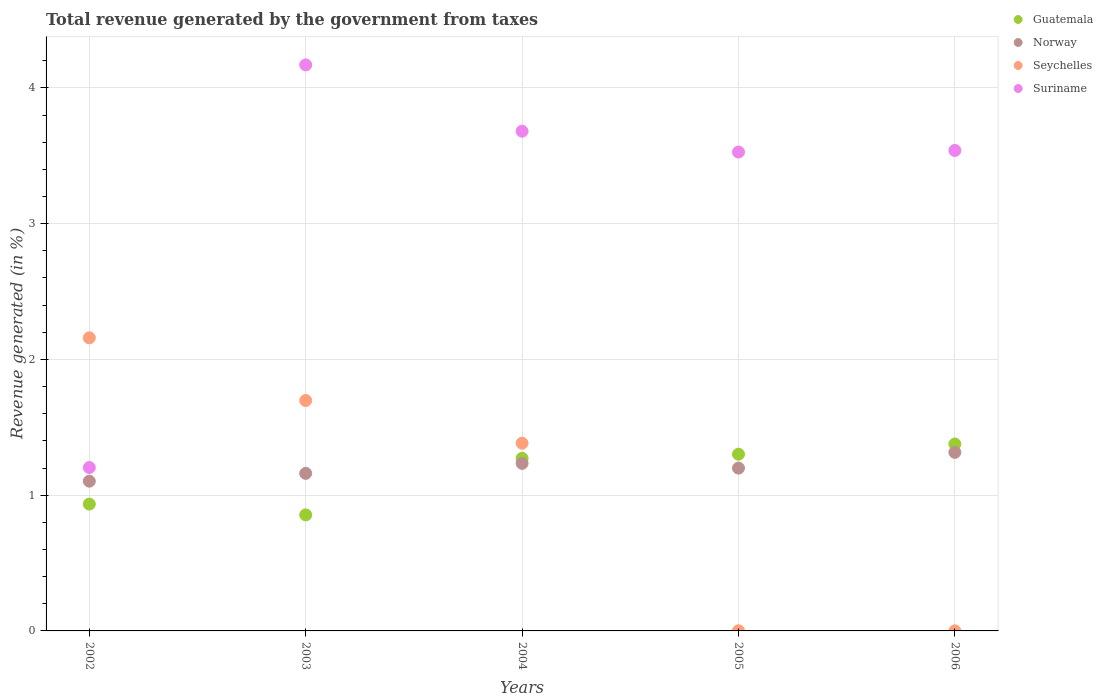Is the number of dotlines equal to the number of legend labels?
Your answer should be very brief. Yes. What is the total revenue generated in Suriname in 2006?
Offer a terse response. 3.54. Across all years, what is the maximum total revenue generated in Norway?
Offer a very short reply. 1.32. Across all years, what is the minimum total revenue generated in Guatemala?
Offer a very short reply. 0.85. What is the total total revenue generated in Guatemala in the graph?
Offer a very short reply. 5.74. What is the difference between the total revenue generated in Norway in 2003 and that in 2004?
Your answer should be compact. -0.07. What is the difference between the total revenue generated in Suriname in 2006 and the total revenue generated in Guatemala in 2005?
Give a very brief answer. 2.24. What is the average total revenue generated in Norway per year?
Provide a short and direct response. 1.2. In the year 2003, what is the difference between the total revenue generated in Seychelles and total revenue generated in Norway?
Offer a terse response. 0.54. What is the ratio of the total revenue generated in Guatemala in 2002 to that in 2004?
Keep it short and to the point. 0.73. Is the total revenue generated in Suriname in 2004 less than that in 2005?
Your answer should be compact. No. What is the difference between the highest and the second highest total revenue generated in Seychelles?
Offer a terse response. 0.46. What is the difference between the highest and the lowest total revenue generated in Seychelles?
Provide a succinct answer. 2.16. Is the sum of the total revenue generated in Norway in 2005 and 2006 greater than the maximum total revenue generated in Seychelles across all years?
Provide a succinct answer. Yes. Does the total revenue generated in Norway monotonically increase over the years?
Offer a very short reply. No. Is the total revenue generated in Suriname strictly greater than the total revenue generated in Guatemala over the years?
Your answer should be very brief. Yes. Is the total revenue generated in Suriname strictly less than the total revenue generated in Norway over the years?
Offer a very short reply. No. How many dotlines are there?
Provide a short and direct response. 4. Are the values on the major ticks of Y-axis written in scientific E-notation?
Your answer should be very brief. No. Does the graph contain any zero values?
Keep it short and to the point. No. What is the title of the graph?
Your response must be concise. Total revenue generated by the government from taxes. Does "Estonia" appear as one of the legend labels in the graph?
Give a very brief answer. No. What is the label or title of the Y-axis?
Offer a terse response. Revenue generated (in %). What is the Revenue generated (in %) of Guatemala in 2002?
Provide a succinct answer. 0.93. What is the Revenue generated (in %) in Norway in 2002?
Your answer should be very brief. 1.1. What is the Revenue generated (in %) of Seychelles in 2002?
Provide a succinct answer. 2.16. What is the Revenue generated (in %) of Suriname in 2002?
Provide a succinct answer. 1.2. What is the Revenue generated (in %) of Guatemala in 2003?
Offer a terse response. 0.85. What is the Revenue generated (in %) of Norway in 2003?
Give a very brief answer. 1.16. What is the Revenue generated (in %) in Seychelles in 2003?
Your answer should be compact. 1.7. What is the Revenue generated (in %) of Suriname in 2003?
Ensure brevity in your answer.  4.17. What is the Revenue generated (in %) of Guatemala in 2004?
Your response must be concise. 1.27. What is the Revenue generated (in %) of Norway in 2004?
Provide a short and direct response. 1.23. What is the Revenue generated (in %) of Seychelles in 2004?
Make the answer very short. 1.38. What is the Revenue generated (in %) in Suriname in 2004?
Provide a succinct answer. 3.68. What is the Revenue generated (in %) of Guatemala in 2005?
Offer a very short reply. 1.3. What is the Revenue generated (in %) in Norway in 2005?
Your response must be concise. 1.2. What is the Revenue generated (in %) in Seychelles in 2005?
Keep it short and to the point. 0. What is the Revenue generated (in %) in Suriname in 2005?
Offer a terse response. 3.53. What is the Revenue generated (in %) in Guatemala in 2006?
Provide a short and direct response. 1.38. What is the Revenue generated (in %) of Norway in 2006?
Offer a terse response. 1.32. What is the Revenue generated (in %) of Seychelles in 2006?
Your response must be concise. 0. What is the Revenue generated (in %) of Suriname in 2006?
Offer a terse response. 3.54. Across all years, what is the maximum Revenue generated (in %) in Guatemala?
Provide a succinct answer. 1.38. Across all years, what is the maximum Revenue generated (in %) in Norway?
Your answer should be very brief. 1.32. Across all years, what is the maximum Revenue generated (in %) of Seychelles?
Keep it short and to the point. 2.16. Across all years, what is the maximum Revenue generated (in %) in Suriname?
Keep it short and to the point. 4.17. Across all years, what is the minimum Revenue generated (in %) of Guatemala?
Offer a terse response. 0.85. Across all years, what is the minimum Revenue generated (in %) in Norway?
Offer a very short reply. 1.1. Across all years, what is the minimum Revenue generated (in %) in Seychelles?
Ensure brevity in your answer.  0. Across all years, what is the minimum Revenue generated (in %) of Suriname?
Offer a very short reply. 1.2. What is the total Revenue generated (in %) in Guatemala in the graph?
Your answer should be very brief. 5.74. What is the total Revenue generated (in %) in Norway in the graph?
Make the answer very short. 6.01. What is the total Revenue generated (in %) in Seychelles in the graph?
Keep it short and to the point. 5.24. What is the total Revenue generated (in %) in Suriname in the graph?
Give a very brief answer. 16.12. What is the difference between the Revenue generated (in %) of Guatemala in 2002 and that in 2003?
Ensure brevity in your answer.  0.08. What is the difference between the Revenue generated (in %) of Norway in 2002 and that in 2003?
Provide a succinct answer. -0.06. What is the difference between the Revenue generated (in %) in Seychelles in 2002 and that in 2003?
Your answer should be very brief. 0.46. What is the difference between the Revenue generated (in %) of Suriname in 2002 and that in 2003?
Keep it short and to the point. -2.97. What is the difference between the Revenue generated (in %) in Guatemala in 2002 and that in 2004?
Make the answer very short. -0.34. What is the difference between the Revenue generated (in %) of Norway in 2002 and that in 2004?
Make the answer very short. -0.13. What is the difference between the Revenue generated (in %) of Seychelles in 2002 and that in 2004?
Provide a short and direct response. 0.78. What is the difference between the Revenue generated (in %) of Suriname in 2002 and that in 2004?
Make the answer very short. -2.48. What is the difference between the Revenue generated (in %) in Guatemala in 2002 and that in 2005?
Keep it short and to the point. -0.37. What is the difference between the Revenue generated (in %) in Norway in 2002 and that in 2005?
Provide a succinct answer. -0.1. What is the difference between the Revenue generated (in %) of Seychelles in 2002 and that in 2005?
Give a very brief answer. 2.16. What is the difference between the Revenue generated (in %) in Suriname in 2002 and that in 2005?
Provide a short and direct response. -2.32. What is the difference between the Revenue generated (in %) of Guatemala in 2002 and that in 2006?
Make the answer very short. -0.44. What is the difference between the Revenue generated (in %) of Norway in 2002 and that in 2006?
Your response must be concise. -0.21. What is the difference between the Revenue generated (in %) of Seychelles in 2002 and that in 2006?
Your response must be concise. 2.16. What is the difference between the Revenue generated (in %) of Suriname in 2002 and that in 2006?
Your answer should be very brief. -2.34. What is the difference between the Revenue generated (in %) of Guatemala in 2003 and that in 2004?
Make the answer very short. -0.42. What is the difference between the Revenue generated (in %) of Norway in 2003 and that in 2004?
Offer a very short reply. -0.07. What is the difference between the Revenue generated (in %) of Seychelles in 2003 and that in 2004?
Keep it short and to the point. 0.31. What is the difference between the Revenue generated (in %) of Suriname in 2003 and that in 2004?
Make the answer very short. 0.49. What is the difference between the Revenue generated (in %) in Guatemala in 2003 and that in 2005?
Give a very brief answer. -0.45. What is the difference between the Revenue generated (in %) in Norway in 2003 and that in 2005?
Provide a short and direct response. -0.04. What is the difference between the Revenue generated (in %) in Seychelles in 2003 and that in 2005?
Keep it short and to the point. 1.7. What is the difference between the Revenue generated (in %) in Suriname in 2003 and that in 2005?
Give a very brief answer. 0.64. What is the difference between the Revenue generated (in %) of Guatemala in 2003 and that in 2006?
Offer a terse response. -0.52. What is the difference between the Revenue generated (in %) in Norway in 2003 and that in 2006?
Provide a short and direct response. -0.15. What is the difference between the Revenue generated (in %) in Seychelles in 2003 and that in 2006?
Give a very brief answer. 1.7. What is the difference between the Revenue generated (in %) in Suriname in 2003 and that in 2006?
Offer a very short reply. 0.63. What is the difference between the Revenue generated (in %) in Guatemala in 2004 and that in 2005?
Your response must be concise. -0.03. What is the difference between the Revenue generated (in %) of Norway in 2004 and that in 2005?
Offer a very short reply. 0.04. What is the difference between the Revenue generated (in %) in Seychelles in 2004 and that in 2005?
Provide a short and direct response. 1.38. What is the difference between the Revenue generated (in %) of Suriname in 2004 and that in 2005?
Offer a terse response. 0.15. What is the difference between the Revenue generated (in %) in Guatemala in 2004 and that in 2006?
Your answer should be very brief. -0.11. What is the difference between the Revenue generated (in %) of Norway in 2004 and that in 2006?
Provide a short and direct response. -0.08. What is the difference between the Revenue generated (in %) in Seychelles in 2004 and that in 2006?
Keep it short and to the point. 1.38. What is the difference between the Revenue generated (in %) in Suriname in 2004 and that in 2006?
Provide a succinct answer. 0.14. What is the difference between the Revenue generated (in %) of Guatemala in 2005 and that in 2006?
Your response must be concise. -0.08. What is the difference between the Revenue generated (in %) in Norway in 2005 and that in 2006?
Offer a terse response. -0.12. What is the difference between the Revenue generated (in %) of Seychelles in 2005 and that in 2006?
Provide a succinct answer. 0. What is the difference between the Revenue generated (in %) of Suriname in 2005 and that in 2006?
Give a very brief answer. -0.01. What is the difference between the Revenue generated (in %) of Guatemala in 2002 and the Revenue generated (in %) of Norway in 2003?
Provide a succinct answer. -0.23. What is the difference between the Revenue generated (in %) in Guatemala in 2002 and the Revenue generated (in %) in Seychelles in 2003?
Offer a very short reply. -0.76. What is the difference between the Revenue generated (in %) in Guatemala in 2002 and the Revenue generated (in %) in Suriname in 2003?
Your response must be concise. -3.24. What is the difference between the Revenue generated (in %) of Norway in 2002 and the Revenue generated (in %) of Seychelles in 2003?
Keep it short and to the point. -0.59. What is the difference between the Revenue generated (in %) of Norway in 2002 and the Revenue generated (in %) of Suriname in 2003?
Make the answer very short. -3.07. What is the difference between the Revenue generated (in %) in Seychelles in 2002 and the Revenue generated (in %) in Suriname in 2003?
Make the answer very short. -2.01. What is the difference between the Revenue generated (in %) of Guatemala in 2002 and the Revenue generated (in %) of Norway in 2004?
Offer a terse response. -0.3. What is the difference between the Revenue generated (in %) of Guatemala in 2002 and the Revenue generated (in %) of Seychelles in 2004?
Offer a very short reply. -0.45. What is the difference between the Revenue generated (in %) in Guatemala in 2002 and the Revenue generated (in %) in Suriname in 2004?
Provide a short and direct response. -2.75. What is the difference between the Revenue generated (in %) of Norway in 2002 and the Revenue generated (in %) of Seychelles in 2004?
Make the answer very short. -0.28. What is the difference between the Revenue generated (in %) in Norway in 2002 and the Revenue generated (in %) in Suriname in 2004?
Provide a short and direct response. -2.58. What is the difference between the Revenue generated (in %) in Seychelles in 2002 and the Revenue generated (in %) in Suriname in 2004?
Make the answer very short. -1.52. What is the difference between the Revenue generated (in %) of Guatemala in 2002 and the Revenue generated (in %) of Norway in 2005?
Make the answer very short. -0.26. What is the difference between the Revenue generated (in %) in Guatemala in 2002 and the Revenue generated (in %) in Suriname in 2005?
Your answer should be compact. -2.59. What is the difference between the Revenue generated (in %) of Norway in 2002 and the Revenue generated (in %) of Seychelles in 2005?
Make the answer very short. 1.1. What is the difference between the Revenue generated (in %) of Norway in 2002 and the Revenue generated (in %) of Suriname in 2005?
Your answer should be very brief. -2.42. What is the difference between the Revenue generated (in %) of Seychelles in 2002 and the Revenue generated (in %) of Suriname in 2005?
Give a very brief answer. -1.37. What is the difference between the Revenue generated (in %) in Guatemala in 2002 and the Revenue generated (in %) in Norway in 2006?
Your response must be concise. -0.38. What is the difference between the Revenue generated (in %) of Guatemala in 2002 and the Revenue generated (in %) of Seychelles in 2006?
Keep it short and to the point. 0.93. What is the difference between the Revenue generated (in %) of Guatemala in 2002 and the Revenue generated (in %) of Suriname in 2006?
Provide a short and direct response. -2.61. What is the difference between the Revenue generated (in %) of Norway in 2002 and the Revenue generated (in %) of Seychelles in 2006?
Provide a short and direct response. 1.1. What is the difference between the Revenue generated (in %) in Norway in 2002 and the Revenue generated (in %) in Suriname in 2006?
Offer a terse response. -2.44. What is the difference between the Revenue generated (in %) in Seychelles in 2002 and the Revenue generated (in %) in Suriname in 2006?
Your response must be concise. -1.38. What is the difference between the Revenue generated (in %) in Guatemala in 2003 and the Revenue generated (in %) in Norway in 2004?
Keep it short and to the point. -0.38. What is the difference between the Revenue generated (in %) of Guatemala in 2003 and the Revenue generated (in %) of Seychelles in 2004?
Offer a terse response. -0.53. What is the difference between the Revenue generated (in %) in Guatemala in 2003 and the Revenue generated (in %) in Suriname in 2004?
Offer a very short reply. -2.83. What is the difference between the Revenue generated (in %) in Norway in 2003 and the Revenue generated (in %) in Seychelles in 2004?
Your response must be concise. -0.22. What is the difference between the Revenue generated (in %) of Norway in 2003 and the Revenue generated (in %) of Suriname in 2004?
Offer a terse response. -2.52. What is the difference between the Revenue generated (in %) of Seychelles in 2003 and the Revenue generated (in %) of Suriname in 2004?
Your response must be concise. -1.98. What is the difference between the Revenue generated (in %) in Guatemala in 2003 and the Revenue generated (in %) in Norway in 2005?
Keep it short and to the point. -0.34. What is the difference between the Revenue generated (in %) of Guatemala in 2003 and the Revenue generated (in %) of Seychelles in 2005?
Offer a very short reply. 0.85. What is the difference between the Revenue generated (in %) of Guatemala in 2003 and the Revenue generated (in %) of Suriname in 2005?
Make the answer very short. -2.67. What is the difference between the Revenue generated (in %) in Norway in 2003 and the Revenue generated (in %) in Seychelles in 2005?
Offer a very short reply. 1.16. What is the difference between the Revenue generated (in %) of Norway in 2003 and the Revenue generated (in %) of Suriname in 2005?
Give a very brief answer. -2.37. What is the difference between the Revenue generated (in %) in Seychelles in 2003 and the Revenue generated (in %) in Suriname in 2005?
Your response must be concise. -1.83. What is the difference between the Revenue generated (in %) of Guatemala in 2003 and the Revenue generated (in %) of Norway in 2006?
Your response must be concise. -0.46. What is the difference between the Revenue generated (in %) in Guatemala in 2003 and the Revenue generated (in %) in Seychelles in 2006?
Ensure brevity in your answer.  0.85. What is the difference between the Revenue generated (in %) of Guatemala in 2003 and the Revenue generated (in %) of Suriname in 2006?
Keep it short and to the point. -2.68. What is the difference between the Revenue generated (in %) of Norway in 2003 and the Revenue generated (in %) of Seychelles in 2006?
Offer a very short reply. 1.16. What is the difference between the Revenue generated (in %) in Norway in 2003 and the Revenue generated (in %) in Suriname in 2006?
Offer a very short reply. -2.38. What is the difference between the Revenue generated (in %) of Seychelles in 2003 and the Revenue generated (in %) of Suriname in 2006?
Your answer should be very brief. -1.84. What is the difference between the Revenue generated (in %) of Guatemala in 2004 and the Revenue generated (in %) of Norway in 2005?
Keep it short and to the point. 0.07. What is the difference between the Revenue generated (in %) in Guatemala in 2004 and the Revenue generated (in %) in Seychelles in 2005?
Provide a short and direct response. 1.27. What is the difference between the Revenue generated (in %) of Guatemala in 2004 and the Revenue generated (in %) of Suriname in 2005?
Offer a very short reply. -2.26. What is the difference between the Revenue generated (in %) of Norway in 2004 and the Revenue generated (in %) of Seychelles in 2005?
Provide a succinct answer. 1.23. What is the difference between the Revenue generated (in %) of Norway in 2004 and the Revenue generated (in %) of Suriname in 2005?
Provide a succinct answer. -2.29. What is the difference between the Revenue generated (in %) in Seychelles in 2004 and the Revenue generated (in %) in Suriname in 2005?
Provide a short and direct response. -2.14. What is the difference between the Revenue generated (in %) of Guatemala in 2004 and the Revenue generated (in %) of Norway in 2006?
Keep it short and to the point. -0.04. What is the difference between the Revenue generated (in %) of Guatemala in 2004 and the Revenue generated (in %) of Seychelles in 2006?
Your answer should be compact. 1.27. What is the difference between the Revenue generated (in %) in Guatemala in 2004 and the Revenue generated (in %) in Suriname in 2006?
Offer a terse response. -2.27. What is the difference between the Revenue generated (in %) in Norway in 2004 and the Revenue generated (in %) in Seychelles in 2006?
Your response must be concise. 1.23. What is the difference between the Revenue generated (in %) of Norway in 2004 and the Revenue generated (in %) of Suriname in 2006?
Keep it short and to the point. -2.31. What is the difference between the Revenue generated (in %) in Seychelles in 2004 and the Revenue generated (in %) in Suriname in 2006?
Keep it short and to the point. -2.16. What is the difference between the Revenue generated (in %) in Guatemala in 2005 and the Revenue generated (in %) in Norway in 2006?
Offer a terse response. -0.01. What is the difference between the Revenue generated (in %) of Guatemala in 2005 and the Revenue generated (in %) of Seychelles in 2006?
Keep it short and to the point. 1.3. What is the difference between the Revenue generated (in %) of Guatemala in 2005 and the Revenue generated (in %) of Suriname in 2006?
Offer a terse response. -2.24. What is the difference between the Revenue generated (in %) of Norway in 2005 and the Revenue generated (in %) of Seychelles in 2006?
Make the answer very short. 1.2. What is the difference between the Revenue generated (in %) of Norway in 2005 and the Revenue generated (in %) of Suriname in 2006?
Ensure brevity in your answer.  -2.34. What is the difference between the Revenue generated (in %) in Seychelles in 2005 and the Revenue generated (in %) in Suriname in 2006?
Give a very brief answer. -3.54. What is the average Revenue generated (in %) in Guatemala per year?
Provide a short and direct response. 1.15. What is the average Revenue generated (in %) of Norway per year?
Give a very brief answer. 1.2. What is the average Revenue generated (in %) in Seychelles per year?
Give a very brief answer. 1.05. What is the average Revenue generated (in %) of Suriname per year?
Your response must be concise. 3.22. In the year 2002, what is the difference between the Revenue generated (in %) in Guatemala and Revenue generated (in %) in Norway?
Offer a very short reply. -0.17. In the year 2002, what is the difference between the Revenue generated (in %) in Guatemala and Revenue generated (in %) in Seychelles?
Your answer should be compact. -1.22. In the year 2002, what is the difference between the Revenue generated (in %) of Guatemala and Revenue generated (in %) of Suriname?
Your answer should be very brief. -0.27. In the year 2002, what is the difference between the Revenue generated (in %) in Norway and Revenue generated (in %) in Seychelles?
Provide a succinct answer. -1.06. In the year 2002, what is the difference between the Revenue generated (in %) of Norway and Revenue generated (in %) of Suriname?
Give a very brief answer. -0.1. In the year 2002, what is the difference between the Revenue generated (in %) in Seychelles and Revenue generated (in %) in Suriname?
Ensure brevity in your answer.  0.96. In the year 2003, what is the difference between the Revenue generated (in %) in Guatemala and Revenue generated (in %) in Norway?
Offer a terse response. -0.31. In the year 2003, what is the difference between the Revenue generated (in %) in Guatemala and Revenue generated (in %) in Seychelles?
Make the answer very short. -0.84. In the year 2003, what is the difference between the Revenue generated (in %) of Guatemala and Revenue generated (in %) of Suriname?
Give a very brief answer. -3.31. In the year 2003, what is the difference between the Revenue generated (in %) of Norway and Revenue generated (in %) of Seychelles?
Provide a short and direct response. -0.54. In the year 2003, what is the difference between the Revenue generated (in %) in Norway and Revenue generated (in %) in Suriname?
Give a very brief answer. -3.01. In the year 2003, what is the difference between the Revenue generated (in %) of Seychelles and Revenue generated (in %) of Suriname?
Give a very brief answer. -2.47. In the year 2004, what is the difference between the Revenue generated (in %) of Guatemala and Revenue generated (in %) of Norway?
Provide a short and direct response. 0.04. In the year 2004, what is the difference between the Revenue generated (in %) in Guatemala and Revenue generated (in %) in Seychelles?
Your answer should be compact. -0.11. In the year 2004, what is the difference between the Revenue generated (in %) of Guatemala and Revenue generated (in %) of Suriname?
Your response must be concise. -2.41. In the year 2004, what is the difference between the Revenue generated (in %) of Norway and Revenue generated (in %) of Seychelles?
Keep it short and to the point. -0.15. In the year 2004, what is the difference between the Revenue generated (in %) in Norway and Revenue generated (in %) in Suriname?
Your answer should be very brief. -2.45. In the year 2004, what is the difference between the Revenue generated (in %) in Seychelles and Revenue generated (in %) in Suriname?
Your answer should be compact. -2.3. In the year 2005, what is the difference between the Revenue generated (in %) in Guatemala and Revenue generated (in %) in Norway?
Offer a very short reply. 0.1. In the year 2005, what is the difference between the Revenue generated (in %) in Guatemala and Revenue generated (in %) in Seychelles?
Make the answer very short. 1.3. In the year 2005, what is the difference between the Revenue generated (in %) in Guatemala and Revenue generated (in %) in Suriname?
Make the answer very short. -2.23. In the year 2005, what is the difference between the Revenue generated (in %) of Norway and Revenue generated (in %) of Seychelles?
Make the answer very short. 1.2. In the year 2005, what is the difference between the Revenue generated (in %) of Norway and Revenue generated (in %) of Suriname?
Keep it short and to the point. -2.33. In the year 2005, what is the difference between the Revenue generated (in %) in Seychelles and Revenue generated (in %) in Suriname?
Provide a succinct answer. -3.53. In the year 2006, what is the difference between the Revenue generated (in %) in Guatemala and Revenue generated (in %) in Norway?
Offer a very short reply. 0.06. In the year 2006, what is the difference between the Revenue generated (in %) of Guatemala and Revenue generated (in %) of Seychelles?
Your answer should be very brief. 1.38. In the year 2006, what is the difference between the Revenue generated (in %) of Guatemala and Revenue generated (in %) of Suriname?
Offer a terse response. -2.16. In the year 2006, what is the difference between the Revenue generated (in %) in Norway and Revenue generated (in %) in Seychelles?
Provide a short and direct response. 1.31. In the year 2006, what is the difference between the Revenue generated (in %) of Norway and Revenue generated (in %) of Suriname?
Make the answer very short. -2.22. In the year 2006, what is the difference between the Revenue generated (in %) in Seychelles and Revenue generated (in %) in Suriname?
Provide a short and direct response. -3.54. What is the ratio of the Revenue generated (in %) in Guatemala in 2002 to that in 2003?
Ensure brevity in your answer.  1.09. What is the ratio of the Revenue generated (in %) of Norway in 2002 to that in 2003?
Your answer should be compact. 0.95. What is the ratio of the Revenue generated (in %) of Seychelles in 2002 to that in 2003?
Your answer should be very brief. 1.27. What is the ratio of the Revenue generated (in %) of Suriname in 2002 to that in 2003?
Ensure brevity in your answer.  0.29. What is the ratio of the Revenue generated (in %) of Guatemala in 2002 to that in 2004?
Provide a succinct answer. 0.73. What is the ratio of the Revenue generated (in %) in Norway in 2002 to that in 2004?
Provide a succinct answer. 0.89. What is the ratio of the Revenue generated (in %) in Seychelles in 2002 to that in 2004?
Your answer should be very brief. 1.56. What is the ratio of the Revenue generated (in %) of Suriname in 2002 to that in 2004?
Give a very brief answer. 0.33. What is the ratio of the Revenue generated (in %) of Guatemala in 2002 to that in 2005?
Make the answer very short. 0.72. What is the ratio of the Revenue generated (in %) of Norway in 2002 to that in 2005?
Provide a short and direct response. 0.92. What is the ratio of the Revenue generated (in %) in Seychelles in 2002 to that in 2005?
Offer a terse response. 1965.96. What is the ratio of the Revenue generated (in %) in Suriname in 2002 to that in 2005?
Make the answer very short. 0.34. What is the ratio of the Revenue generated (in %) of Guatemala in 2002 to that in 2006?
Your response must be concise. 0.68. What is the ratio of the Revenue generated (in %) of Norway in 2002 to that in 2006?
Give a very brief answer. 0.84. What is the ratio of the Revenue generated (in %) in Seychelles in 2002 to that in 2006?
Your answer should be very brief. 3616.83. What is the ratio of the Revenue generated (in %) of Suriname in 2002 to that in 2006?
Your answer should be compact. 0.34. What is the ratio of the Revenue generated (in %) of Guatemala in 2003 to that in 2004?
Your answer should be very brief. 0.67. What is the ratio of the Revenue generated (in %) of Norway in 2003 to that in 2004?
Provide a succinct answer. 0.94. What is the ratio of the Revenue generated (in %) in Seychelles in 2003 to that in 2004?
Give a very brief answer. 1.23. What is the ratio of the Revenue generated (in %) of Suriname in 2003 to that in 2004?
Ensure brevity in your answer.  1.13. What is the ratio of the Revenue generated (in %) of Guatemala in 2003 to that in 2005?
Keep it short and to the point. 0.66. What is the ratio of the Revenue generated (in %) in Norway in 2003 to that in 2005?
Offer a terse response. 0.97. What is the ratio of the Revenue generated (in %) in Seychelles in 2003 to that in 2005?
Make the answer very short. 1545.27. What is the ratio of the Revenue generated (in %) in Suriname in 2003 to that in 2005?
Make the answer very short. 1.18. What is the ratio of the Revenue generated (in %) in Guatemala in 2003 to that in 2006?
Provide a short and direct response. 0.62. What is the ratio of the Revenue generated (in %) in Norway in 2003 to that in 2006?
Provide a succinct answer. 0.88. What is the ratio of the Revenue generated (in %) of Seychelles in 2003 to that in 2006?
Offer a very short reply. 2842.86. What is the ratio of the Revenue generated (in %) in Suriname in 2003 to that in 2006?
Your answer should be very brief. 1.18. What is the ratio of the Revenue generated (in %) in Guatemala in 2004 to that in 2005?
Provide a short and direct response. 0.98. What is the ratio of the Revenue generated (in %) in Norway in 2004 to that in 2005?
Provide a short and direct response. 1.03. What is the ratio of the Revenue generated (in %) of Seychelles in 2004 to that in 2005?
Your answer should be compact. 1259.06. What is the ratio of the Revenue generated (in %) of Suriname in 2004 to that in 2005?
Keep it short and to the point. 1.04. What is the ratio of the Revenue generated (in %) of Guatemala in 2004 to that in 2006?
Your answer should be compact. 0.92. What is the ratio of the Revenue generated (in %) of Norway in 2004 to that in 2006?
Offer a terse response. 0.94. What is the ratio of the Revenue generated (in %) in Seychelles in 2004 to that in 2006?
Keep it short and to the point. 2316.32. What is the ratio of the Revenue generated (in %) of Guatemala in 2005 to that in 2006?
Your answer should be compact. 0.95. What is the ratio of the Revenue generated (in %) of Norway in 2005 to that in 2006?
Provide a succinct answer. 0.91. What is the ratio of the Revenue generated (in %) of Seychelles in 2005 to that in 2006?
Ensure brevity in your answer.  1.84. What is the ratio of the Revenue generated (in %) of Suriname in 2005 to that in 2006?
Offer a very short reply. 1. What is the difference between the highest and the second highest Revenue generated (in %) in Guatemala?
Give a very brief answer. 0.08. What is the difference between the highest and the second highest Revenue generated (in %) in Norway?
Provide a short and direct response. 0.08. What is the difference between the highest and the second highest Revenue generated (in %) of Seychelles?
Make the answer very short. 0.46. What is the difference between the highest and the second highest Revenue generated (in %) of Suriname?
Ensure brevity in your answer.  0.49. What is the difference between the highest and the lowest Revenue generated (in %) of Guatemala?
Offer a terse response. 0.52. What is the difference between the highest and the lowest Revenue generated (in %) of Norway?
Offer a terse response. 0.21. What is the difference between the highest and the lowest Revenue generated (in %) in Seychelles?
Make the answer very short. 2.16. What is the difference between the highest and the lowest Revenue generated (in %) of Suriname?
Provide a short and direct response. 2.97. 